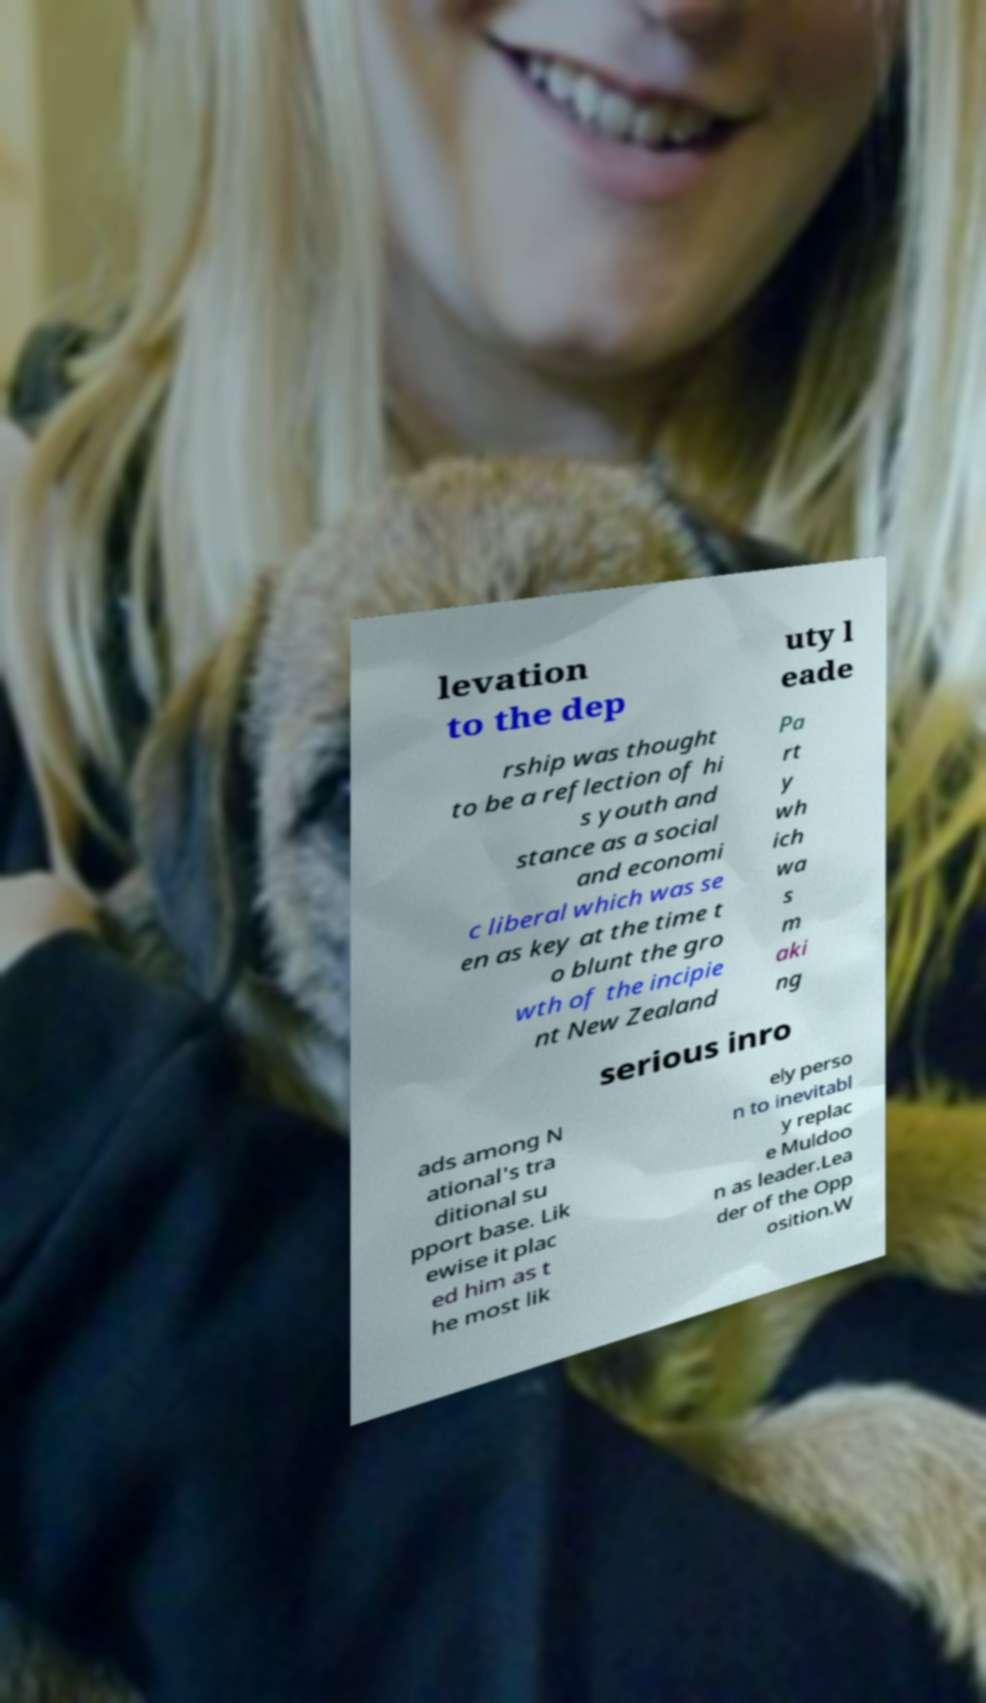Please read and relay the text visible in this image. What does it say? levation to the dep uty l eade rship was thought to be a reflection of hi s youth and stance as a social and economi c liberal which was se en as key at the time t o blunt the gro wth of the incipie nt New Zealand Pa rt y wh ich wa s m aki ng serious inro ads among N ational's tra ditional su pport base. Lik ewise it plac ed him as t he most lik ely perso n to inevitabl y replac e Muldoo n as leader.Lea der of the Opp osition.W 